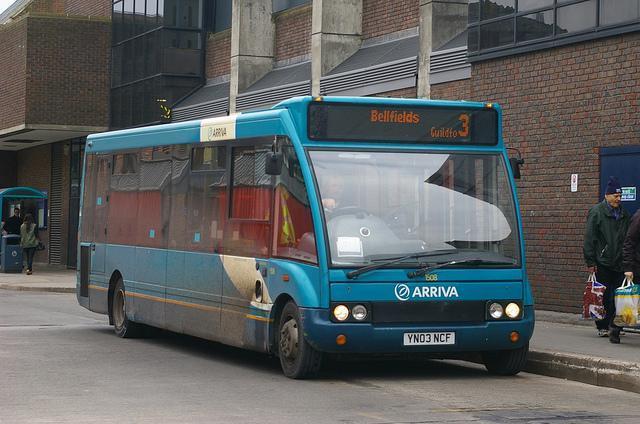How many black umbrellas are in the image?
Give a very brief answer. 0. 